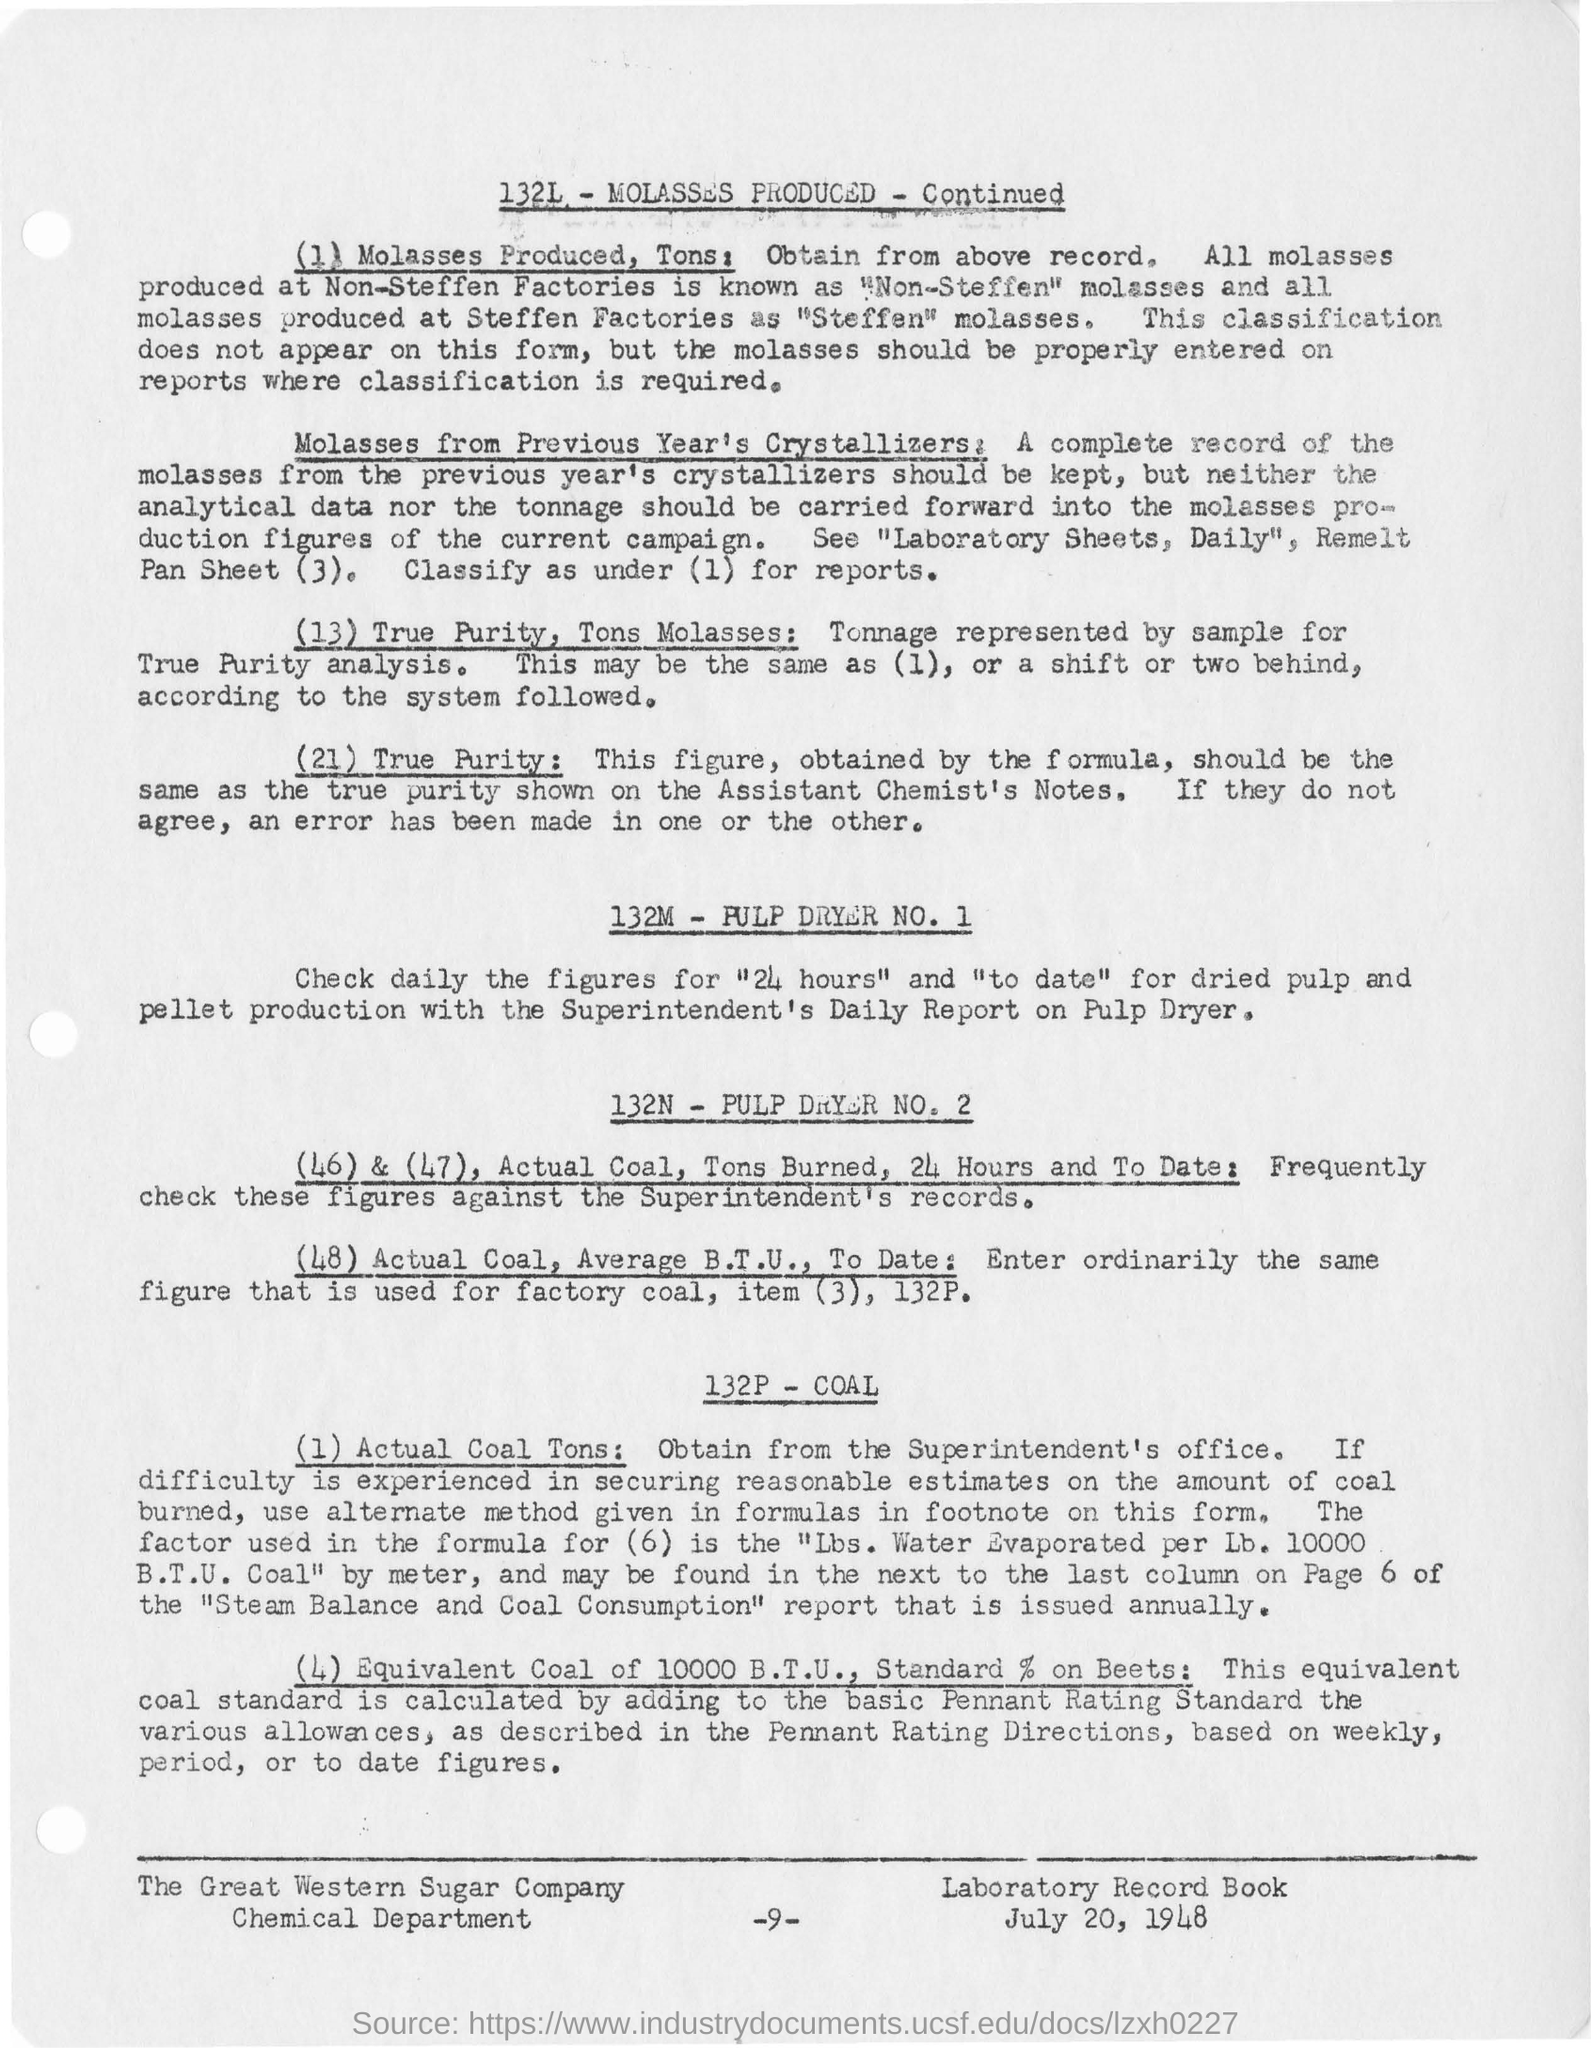When is the document dated?
Your response must be concise. July 20, 1948. Which sugar company's chemical department is mentioned?
Offer a very short reply. The Great Western Sugar Company. 